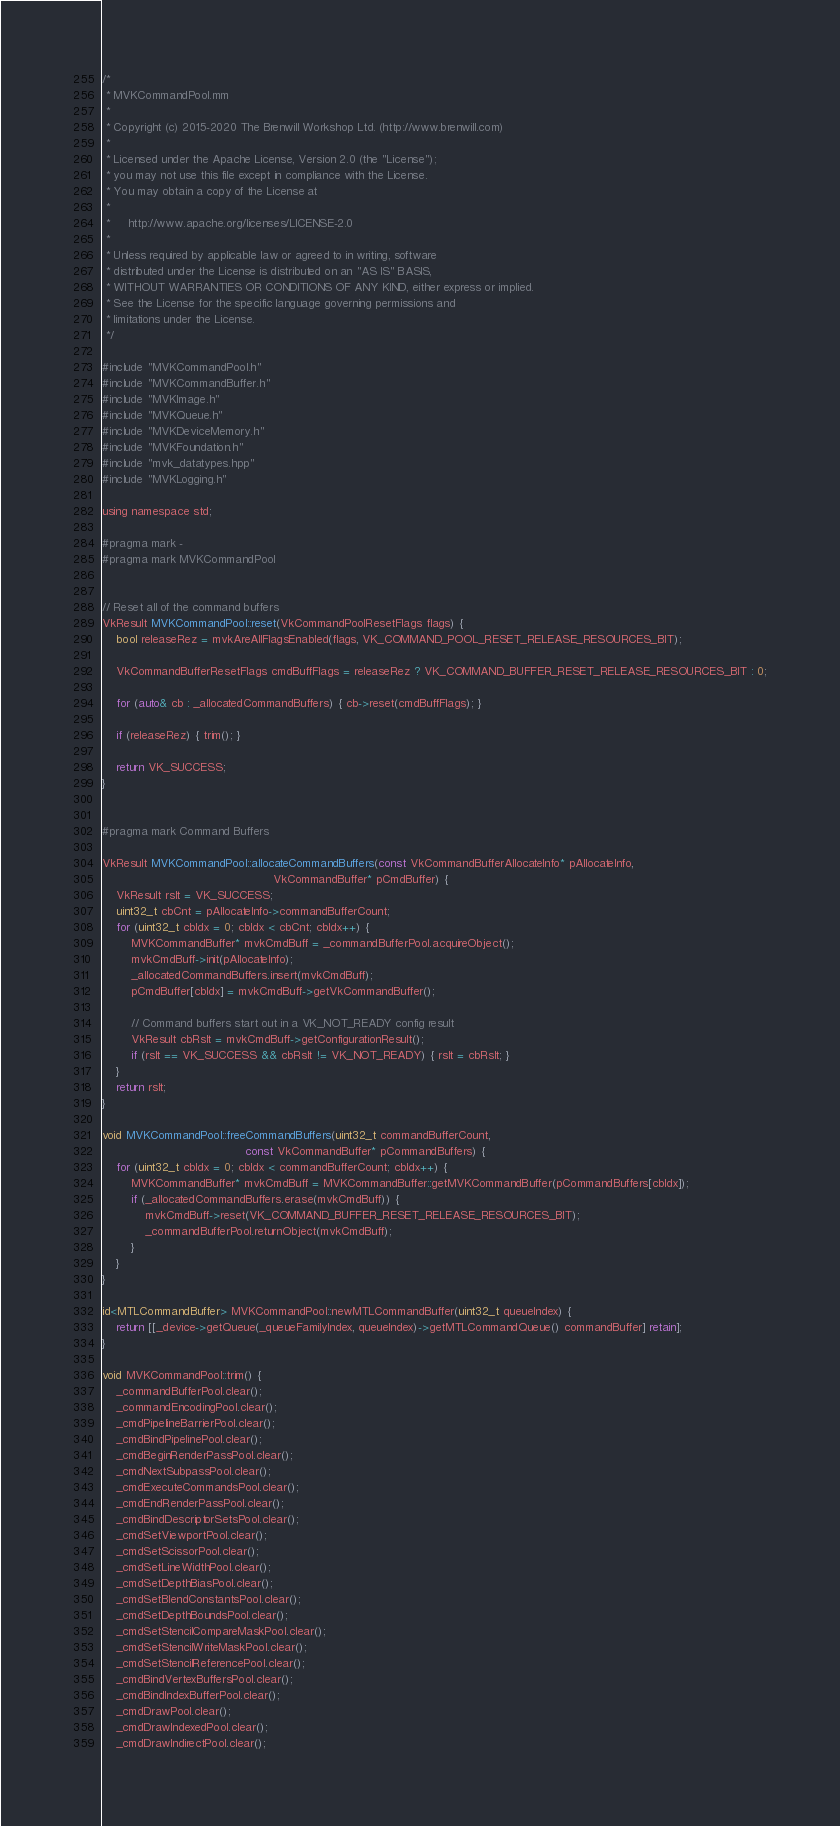<code> <loc_0><loc_0><loc_500><loc_500><_ObjectiveC_>/*
 * MVKCommandPool.mm
 *
 * Copyright (c) 2015-2020 The Brenwill Workshop Ltd. (http://www.brenwill.com)
 *
 * Licensed under the Apache License, Version 2.0 (the "License");
 * you may not use this file except in compliance with the License.
 * You may obtain a copy of the License at
 * 
 *     http://www.apache.org/licenses/LICENSE-2.0
 * 
 * Unless required by applicable law or agreed to in writing, software
 * distributed under the License is distributed on an "AS IS" BASIS,
 * WITHOUT WARRANTIES OR CONDITIONS OF ANY KIND, either express or implied.
 * See the License for the specific language governing permissions and
 * limitations under the License.
 */

#include "MVKCommandPool.h"
#include "MVKCommandBuffer.h"
#include "MVKImage.h"
#include "MVKQueue.h"
#include "MVKDeviceMemory.h"
#include "MVKFoundation.h"
#include "mvk_datatypes.hpp"
#include "MVKLogging.h"

using namespace std;

#pragma mark -
#pragma mark MVKCommandPool


// Reset all of the command buffers
VkResult MVKCommandPool::reset(VkCommandPoolResetFlags flags) {
	bool releaseRez = mvkAreAllFlagsEnabled(flags, VK_COMMAND_POOL_RESET_RELEASE_RESOURCES_BIT);

	VkCommandBufferResetFlags cmdBuffFlags = releaseRez ? VK_COMMAND_BUFFER_RESET_RELEASE_RESOURCES_BIT : 0;

	for (auto& cb : _allocatedCommandBuffers) { cb->reset(cmdBuffFlags); }

	if (releaseRez) { trim(); }

	return VK_SUCCESS;
}


#pragma mark Command Buffers

VkResult MVKCommandPool::allocateCommandBuffers(const VkCommandBufferAllocateInfo* pAllocateInfo,
												VkCommandBuffer* pCmdBuffer) {
	VkResult rslt = VK_SUCCESS;
	uint32_t cbCnt = pAllocateInfo->commandBufferCount;
	for (uint32_t cbIdx = 0; cbIdx < cbCnt; cbIdx++) {
		MVKCommandBuffer* mvkCmdBuff = _commandBufferPool.acquireObject();
		mvkCmdBuff->init(pAllocateInfo);
		_allocatedCommandBuffers.insert(mvkCmdBuff);
        pCmdBuffer[cbIdx] = mvkCmdBuff->getVkCommandBuffer();

		// Command buffers start out in a VK_NOT_READY config result
		VkResult cbRslt = mvkCmdBuff->getConfigurationResult();
		if (rslt == VK_SUCCESS && cbRslt != VK_NOT_READY) { rslt = cbRslt; }
	}
	return rslt;
}

void MVKCommandPool::freeCommandBuffers(uint32_t commandBufferCount,
										const VkCommandBuffer* pCommandBuffers) {
	for (uint32_t cbIdx = 0; cbIdx < commandBufferCount; cbIdx++) {
		MVKCommandBuffer* mvkCmdBuff = MVKCommandBuffer::getMVKCommandBuffer(pCommandBuffers[cbIdx]);
		if (_allocatedCommandBuffers.erase(mvkCmdBuff)) {
			mvkCmdBuff->reset(VK_COMMAND_BUFFER_RESET_RELEASE_RESOURCES_BIT);
			_commandBufferPool.returnObject(mvkCmdBuff);
		}
	}
}

id<MTLCommandBuffer> MVKCommandPool::newMTLCommandBuffer(uint32_t queueIndex) {
	return [[_device->getQueue(_queueFamilyIndex, queueIndex)->getMTLCommandQueue() commandBuffer] retain];
}

void MVKCommandPool::trim() {
	_commandBufferPool.clear();
	_commandEncodingPool.clear();
	_cmdPipelineBarrierPool.clear();
	_cmdBindPipelinePool.clear();
	_cmdBeginRenderPassPool.clear();
	_cmdNextSubpassPool.clear();
	_cmdExecuteCommandsPool.clear();
	_cmdEndRenderPassPool.clear();
	_cmdBindDescriptorSetsPool.clear();
	_cmdSetViewportPool.clear();
	_cmdSetScissorPool.clear();
	_cmdSetLineWidthPool.clear();
	_cmdSetDepthBiasPool.clear();
	_cmdSetBlendConstantsPool.clear();
	_cmdSetDepthBoundsPool.clear();
	_cmdSetStencilCompareMaskPool.clear();
	_cmdSetStencilWriteMaskPool.clear();
	_cmdSetStencilReferencePool.clear();
	_cmdBindVertexBuffersPool.clear();
	_cmdBindIndexBufferPool.clear();
	_cmdDrawPool.clear();
	_cmdDrawIndexedPool.clear();
	_cmdDrawIndirectPool.clear();</code> 